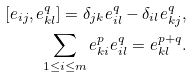<formula> <loc_0><loc_0><loc_500><loc_500>[ e _ { i j } , e _ { k l } ^ { q } ] = \delta _ { j k } e _ { i l } ^ { q } - \delta _ { i l } e ^ { q } _ { k j } , \\ \sum _ { 1 \leq i \leq m } e _ { k i } ^ { p } e _ { i l } ^ { q } = e _ { k l } ^ { p + q } .</formula> 